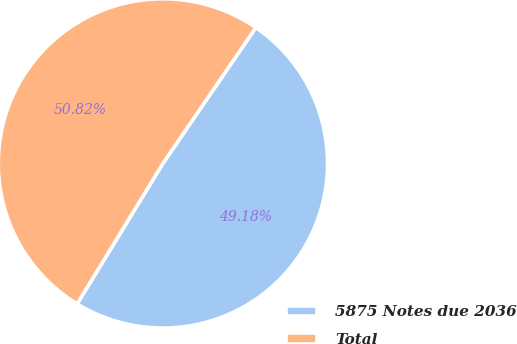Convert chart to OTSL. <chart><loc_0><loc_0><loc_500><loc_500><pie_chart><fcel>5875 Notes due 2036<fcel>Total<nl><fcel>49.18%<fcel>50.82%<nl></chart> 